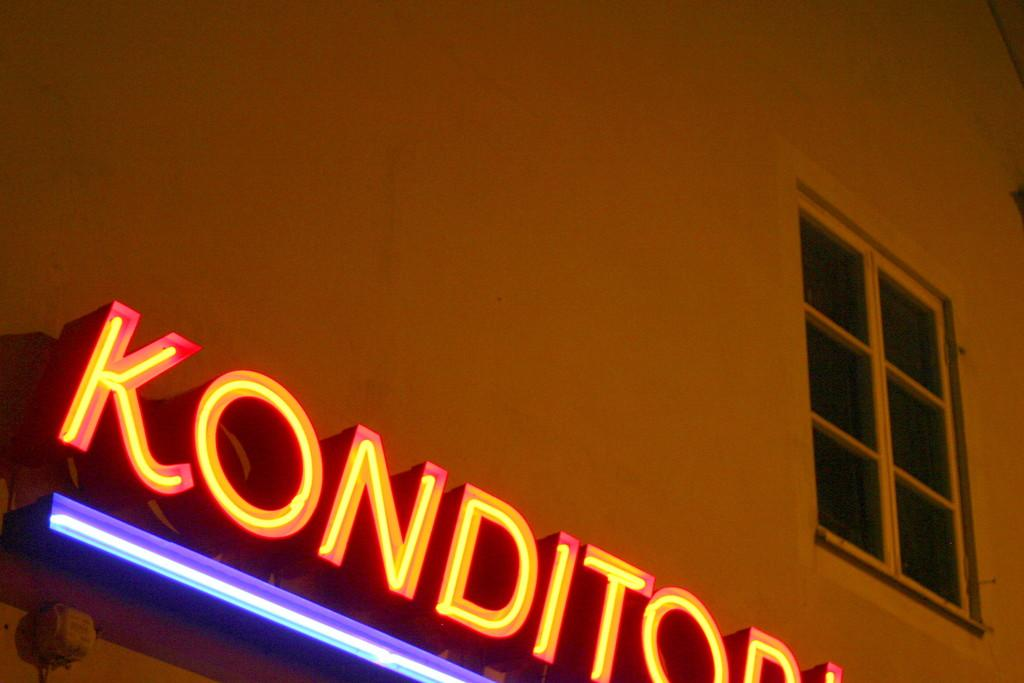What is the main subject of the image? The main subject of the image is a building. What feature can be seen on the building? There are colorful lights on the building. What is the purpose of the colorful lights on the building? Something is written on the building using the colorful lights. How many cherries are hanging from the haircut of the person in the image? There is no person with a haircut or cherries present in the image. 